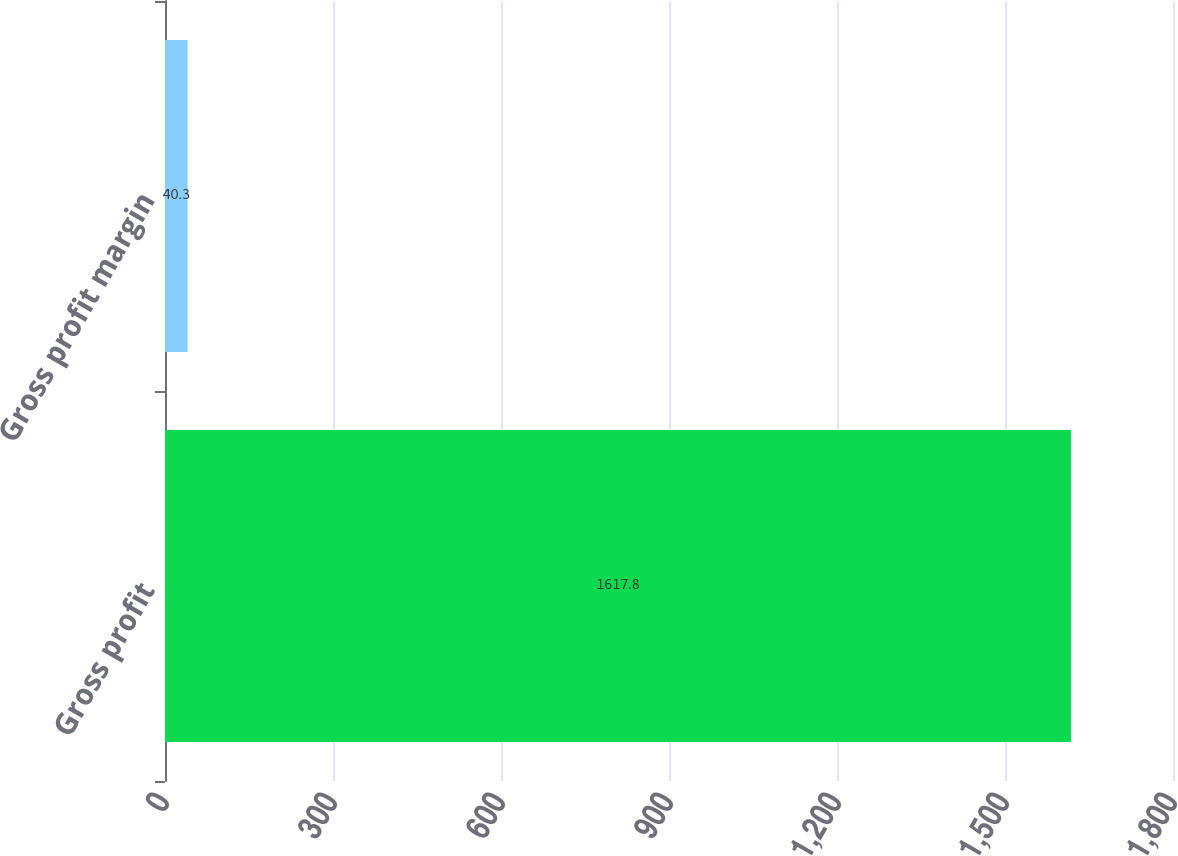Convert chart to OTSL. <chart><loc_0><loc_0><loc_500><loc_500><bar_chart><fcel>Gross profit<fcel>Gross profit margin<nl><fcel>1617.8<fcel>40.3<nl></chart> 